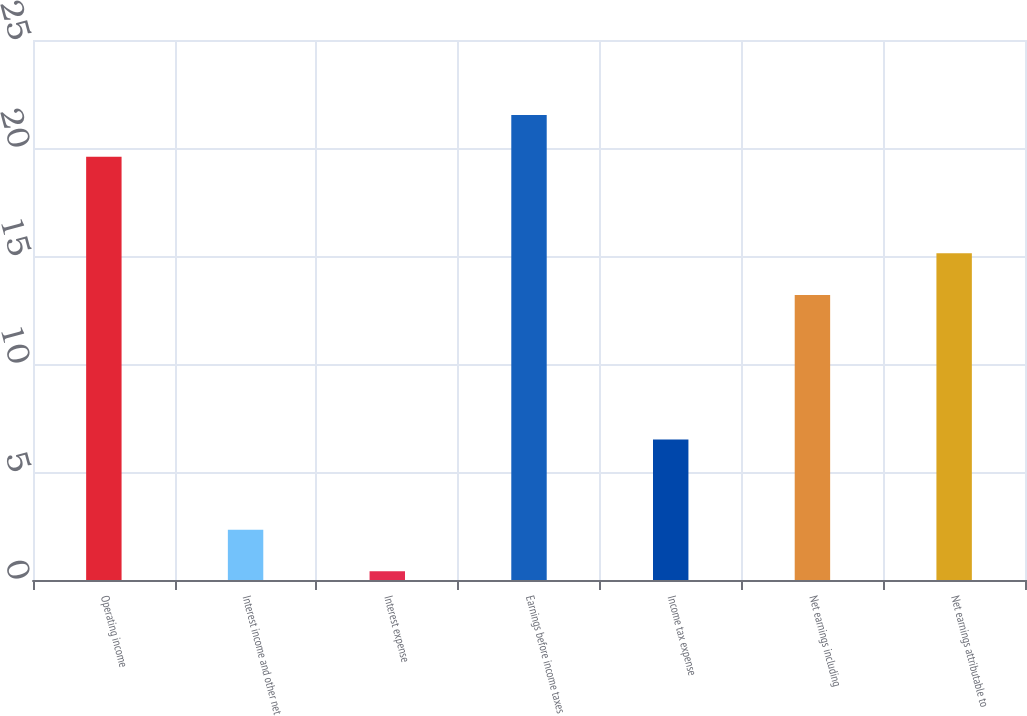Convert chart. <chart><loc_0><loc_0><loc_500><loc_500><bar_chart><fcel>Operating income<fcel>Interest income and other net<fcel>Interest expense<fcel>Earnings before income taxes<fcel>Income tax expense<fcel>Net earnings including<fcel>Net earnings attributable to<nl><fcel>19.6<fcel>2.33<fcel>0.4<fcel>21.53<fcel>6.5<fcel>13.2<fcel>15.13<nl></chart> 